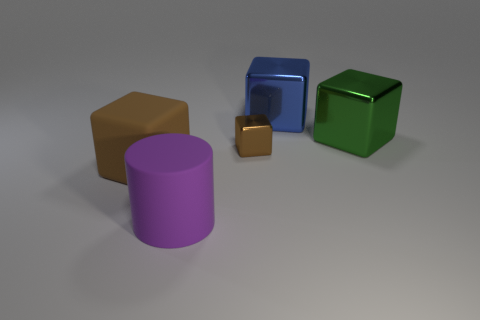Subtract all cyan balls. How many brown blocks are left? 2 Subtract all large green blocks. How many blocks are left? 3 Add 4 brown rubber objects. How many objects exist? 9 Subtract all blue blocks. How many blocks are left? 3 Subtract 1 cubes. How many cubes are left? 3 Subtract all blocks. How many objects are left? 1 Subtract all purple cubes. Subtract all red spheres. How many cubes are left? 4 Subtract all yellow cylinders. Subtract all purple things. How many objects are left? 4 Add 2 big purple matte cylinders. How many big purple matte cylinders are left? 3 Add 3 blue metal objects. How many blue metal objects exist? 4 